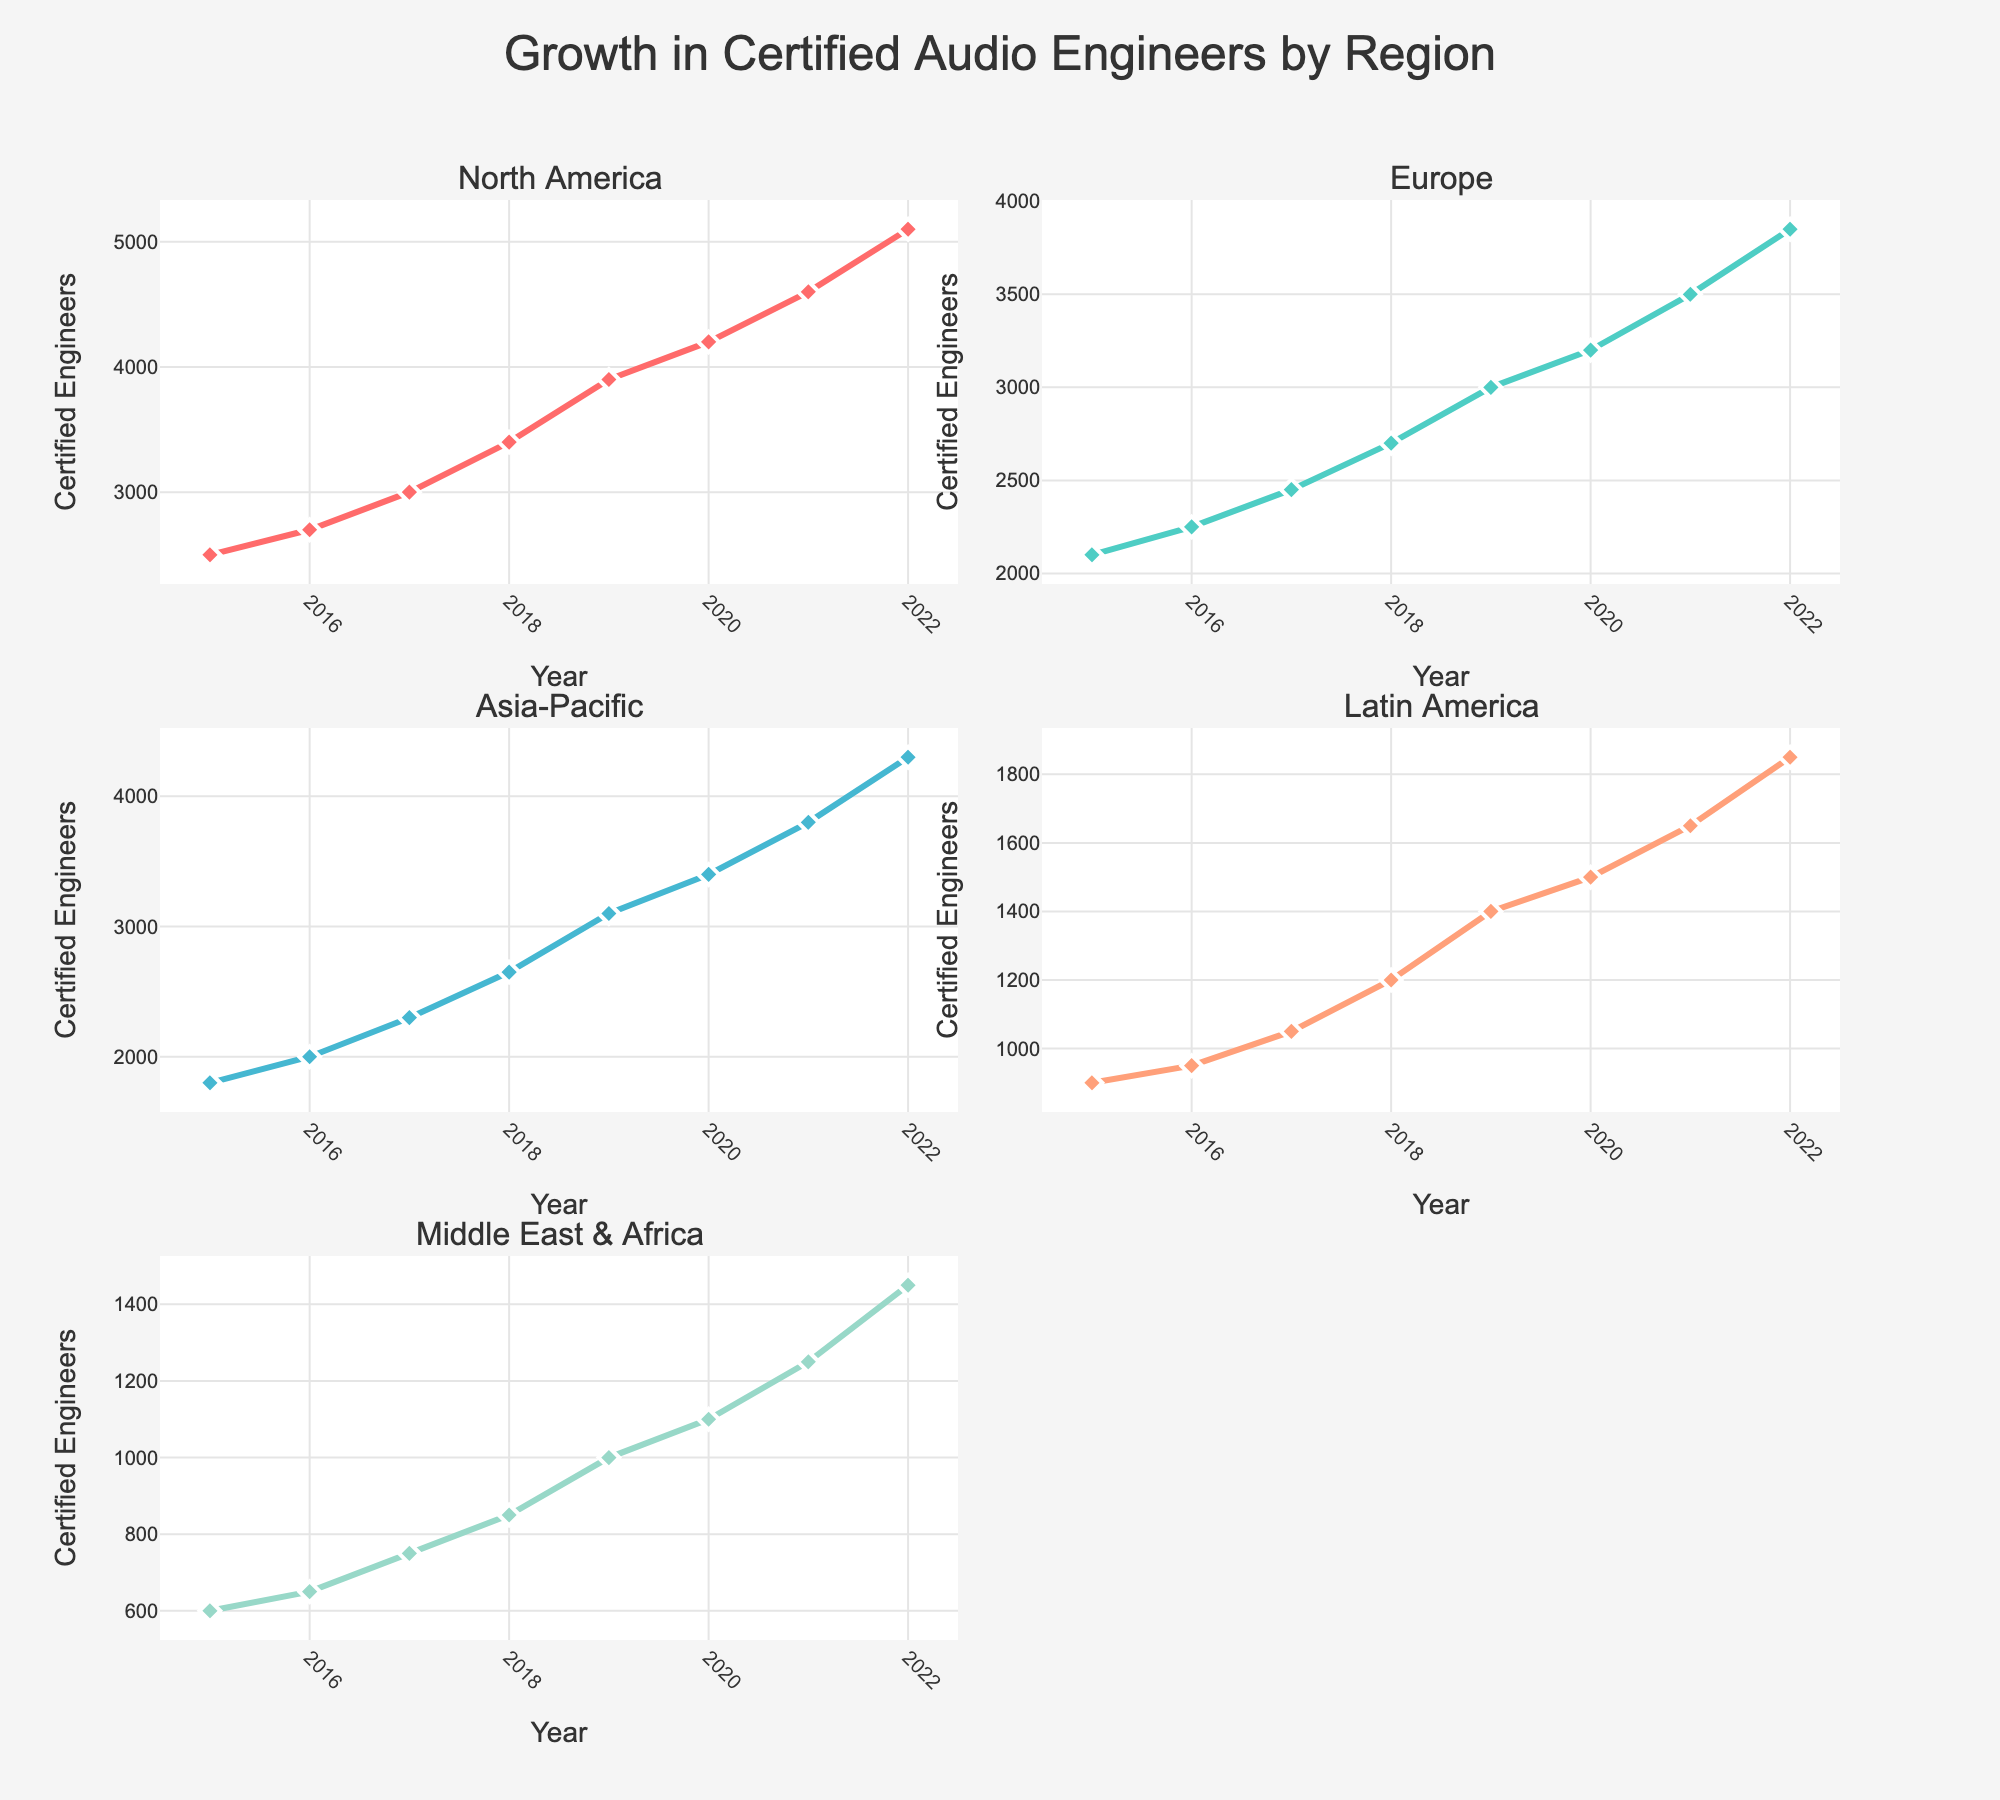What's the overall trend in the number of certified audio engineers in North America from 2015 to 2022? The line chart for North America shows an upward trend in the number of certified audio engineers. Starting from 2500 in 2015, it rises steadily each year to reach 5100 by 2022.
Answer: Upward trend Which region had the highest number of certified audio engineers in 2022? Looking at the 2022 data points, North America had the highest number with 5100 certified audio engineers. The neighboring plots show comparatively lower values.
Answer: North America How much did the number of certified audio engineers in Europe increase from 2015 to 2022? In 2015, Europe had 2100 certified audio engineers. By 2022, this number increased to 3850. So, the increase is 3850 - 2100 = 1750.
Answer: 1750 Compare the growth rate of certified audio engineers between Asia-Pacific and Latin America from 2015 to 2022. Which region grew more? Asia-Pacific started with 1800 in 2015 and reached 4300 in 2022, an increase of 2500. Latin America started with 900 and reached 1850, an increase of 950. So, Asia-Pacific had a higher growth.
Answer: Asia-Pacific What is the average number of certified audio engineers in the Middle East & Africa across the years 2015 to 2022? Sum the numbers for Middle East & Africa from 2015 to 2022 (600 + 650 + 750 + 850 + 1000 + 1100 + 1250 + 1450 = 7650). Divide by the number of years (2022-2015+1 = 8). So, 7650/8 = 956.25.
Answer: 956.25 Which year saw the largest increase in the number of certified audio engineers in North America? By checking the differences year by year in North America's subplot: 2016-2015 = 200, 2017-2016 = 300, 2018-2017 = 400, 2019-2018 = 500, 2020-2019 = 300, 2021-2020 = 400, 2022-2021 = 500. The largest increase was in 2019 and 2022, both with 500.
Answer: 2019 and 2022 How does the trend in Europe compare with the trend in North America? Both regions show an upward trend from 2015 to 2022. However, the increase in North America is more prominent, growing from 2500 to 5100, while Europe grows from 2100 to 3850.
Answer: Both upward; North America more prominent Which two regions had the smallest difference in the number of certified audio engineers in 2022? In 2022, Europe had 3850 and Asia-Pacific had 4300. The difference is 4300 - 3850 = 450, which is the smallest difference among all regional comparisons.
Answer: Europe and Asia-Pacific What was the number of certified audio engineers in Latin America in 2020 and how does it compare with the 2019 number for the same region? The number of certified audio engineers in Latin America in 2020 was 1500, compared to 1400 in 2019, showing an increase of 100.
Answer: 1500 in 2020; increased by 100 from 2019 